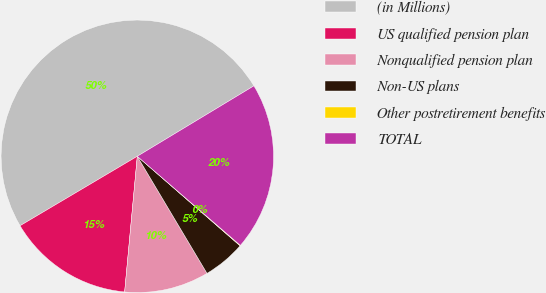Convert chart to OTSL. <chart><loc_0><loc_0><loc_500><loc_500><pie_chart><fcel>(in Millions)<fcel>US qualified pension plan<fcel>Nonqualified pension plan<fcel>Non-US plans<fcel>Other postretirement benefits<fcel>TOTAL<nl><fcel>49.87%<fcel>15.01%<fcel>10.03%<fcel>5.05%<fcel>0.06%<fcel>19.99%<nl></chart> 